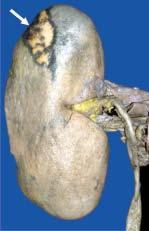what is pale while the margin is haemorrhagic?
Answer the question using a single word or phrase. The central area 